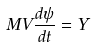<formula> <loc_0><loc_0><loc_500><loc_500>M V \frac { d \psi } { d t } = Y</formula> 